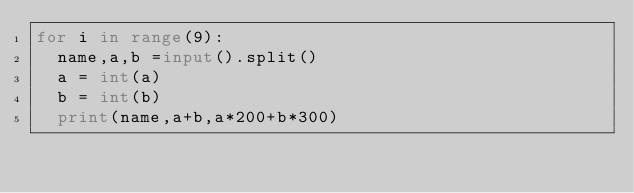<code> <loc_0><loc_0><loc_500><loc_500><_Python_>for i in range(9):
  name,a,b =input().split()
  a = int(a)
  b = int(b)
  print(name,a+b,a*200+b*300)
</code> 